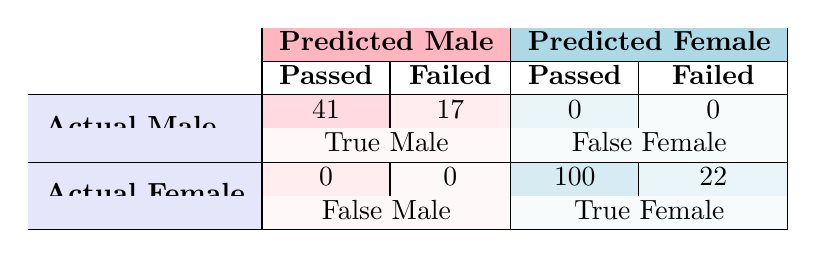What is the total number of students enrolled in the "Feminist Theories" course? The table shows that the "Feminist Theories" course has a Total_Students value of 40.
Answer: 40 What is the number of male students who passed the "Men and Masculinities" course? The table indicates that 15 male students passed the "Men and Masculinities" course, as represented in the Passed section for that course.
Answer: 15 How many total female students passed across all courses combined? To find the total number of female students who passed, we sum the values from the Passed section for female students in each course: 30 (Gender Studies) + 30 (Feminist Theories) + 5 (Men and Masculinities) + 15 (Queer Studies) + 20 (Intersectionality) = 100.
Answer: 100 Did all male students in the "Queer Studies" course pass? In the "Queer Studies" course, 5 male students passed, while there were a total of 8 male students enrolled, meaning not all passed.
Answer: No What is the percentage of female students who passed in the "Intersectionality" course? To calculate the percentage, we take the number of female students who passed (20) divided by the total number of female students enrolled (25) and multiply by 100: (20/25) * 100 = 80%.
Answer: 80% What is the difference in passing rates between male and female students in the "Introduction to Gender Studies" course? Male Passing Rate = 10/15 = 66.67%, Female Passing Rate = 30/35 = 85.71%. The difference is 85.71% - 66.67% = 19.04%.
Answer: 19.04% How many more female students are there than male students in total across all courses? We calculate total female enrollment: 35 + 35 + 10 + 17 + 25 = 122 and total male enrollment: 15 + 5 + 20 + 8 + 10 = 58. The difference is 122 - 58 = 64.
Answer: 64 Did any course have a higher number of failed male students compared to passed male students? By analyzing the courses, we determine the number of failed male students by subtracting passed male from male enrollment. For "Men and Masculinities," 20 male students - 15 passed = 5 failed, yet it’s not higher than passed. The same applies in other courses, thus none had higher fails than passes.
Answer: No What is the total passing rate for female students across all courses? To calculate, we take the total number of female students who passed (100) and divide it by total female enrollment (35 + 35 + 10 + 17 + 25 = 122): (100/122) * 100 ≈ 81.97%.
Answer: 81.97% 